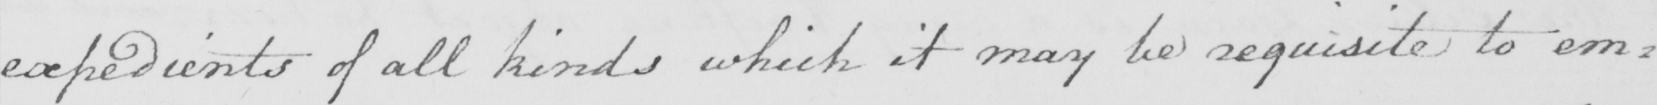Please provide the text content of this handwritten line. expedients of all kinds which it may be requisite to em= 